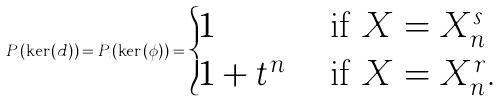Convert formula to latex. <formula><loc_0><loc_0><loc_500><loc_500>P _ { t } ( \ker ( d ) ) = P _ { t } ( \ker ( \phi ) ) = \begin{cases} 1 & \text { if $X = X_{n}^{s}$} \\ 1 + t ^ { n } & \text { if $X = X_{n}^{r}$} . \\ \end{cases}</formula> 